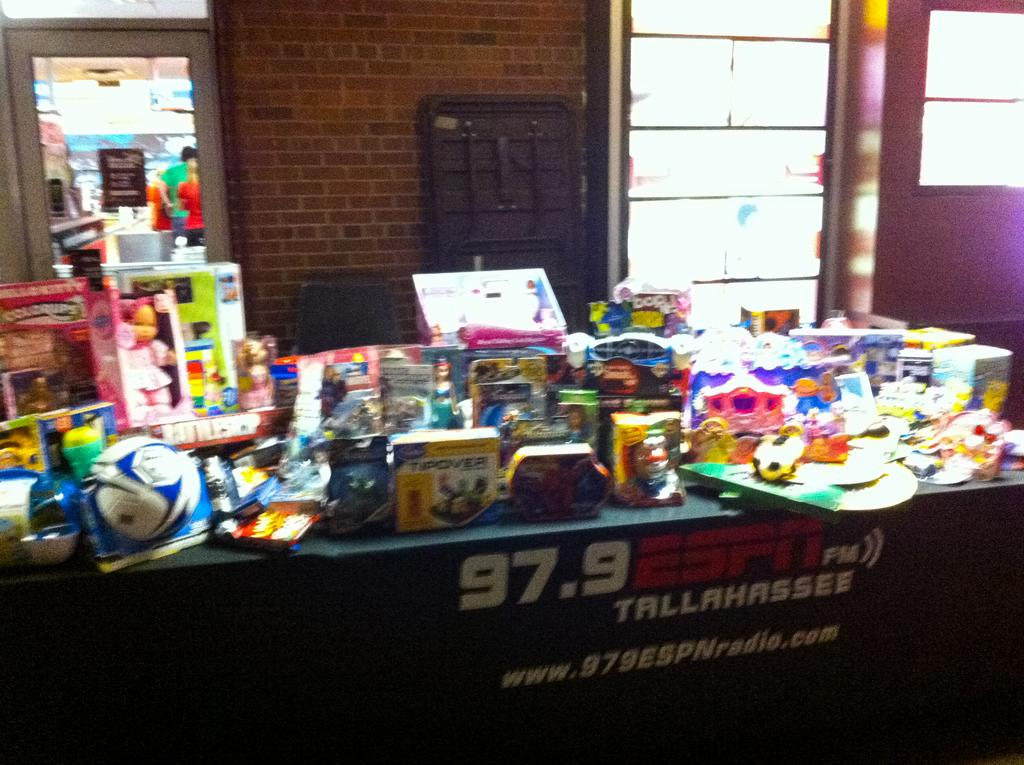<image>
Relay a brief, clear account of the picture shown. A table crowded with toys is sponsored by 97.9 ESPN FM out of Tallahassee. 